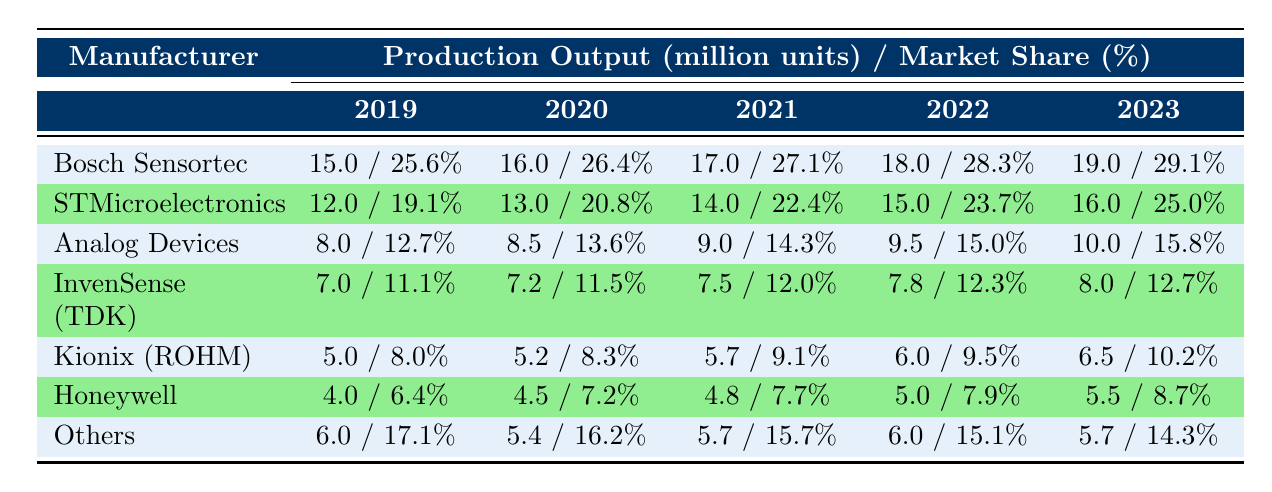What was the production output of Bosch Sensortec in 2022? In 2022, Bosch Sensortec produced 18 million units of accelerometers according to the table.
Answer: 18 million units Which manufacturer had the highest market share in 2021? In 2021, Bosch Sensortec had the highest market share at 27.1%.
Answer: Bosch Sensortec What is the total production output of Analog Devices from 2019 to 2023? The production outputs of Analog Devices are 8 million (2019), 8.5 million (2020), 9 million (2021), 9.5 million (2022), and 10 million (2023). The sum is 8 + 8.5 + 9 + 9.5 + 10 = 45 million units.
Answer: 45 million units Did Honeywell's market share increase every year from 2019 to 2023? To determine this, we check the market share: 6.4% (2019) to 7.2% (2020), 7.7% (2021), 7.9% (2022), and 8.7% (2023). Since there are increases every year, the answer is yes.
Answer: Yes What is the difference in production output between STMicroelectronics in 2023 and 2020? STMicroelectronics produced 16 million units in 2023 and 13 million units in 2020. The difference is 16 - 13 = 3 million units.
Answer: 3 million units What was the average market share of Kionix (ROHM) over the five years? The market shares of Kionix (ROHM) are 8.0%, 8.3%, 9.1%, 9.5%, and 10.2%. The sum is 8.0 + 8.3 + 9.1 + 9.5 + 10.2 = 45.1%. Dividing by 5 gives an average of 45.1 / 5 = 9.02%.
Answer: 9.02% Was there a year when the production output of the "Others" category exceeded Honeywell's output? In checking the years: "Others" produced 6 million in 2019, 5.4 million in 2020, 5.7 million in 2021, 6 million in 2022, and 5.7 million in 2023, while Honeywell produced 4 million (2019), 4.5 million (2020), 4.8 million (2021), 5 million (2022), and 5.5 million (2023). The output of "Others" exceeded that of Honeywell in 2019 and 2022.
Answer: Yes What is the total production output of all manufacturers in 2023? The production outputs in 2023 are: Bosch Sensortec (19 million), STMicroelectronics (16 million), Analog Devices (10 million), InvenSense (8 million), Kionix (6.5 million), Honeywell (5.5 million), and Others (5.7 million). Adding these gives 19 + 16 + 10 + 8 + 6.5 + 5.5 + 5.7 = 71.7 million units.
Answer: 71.7 million units 